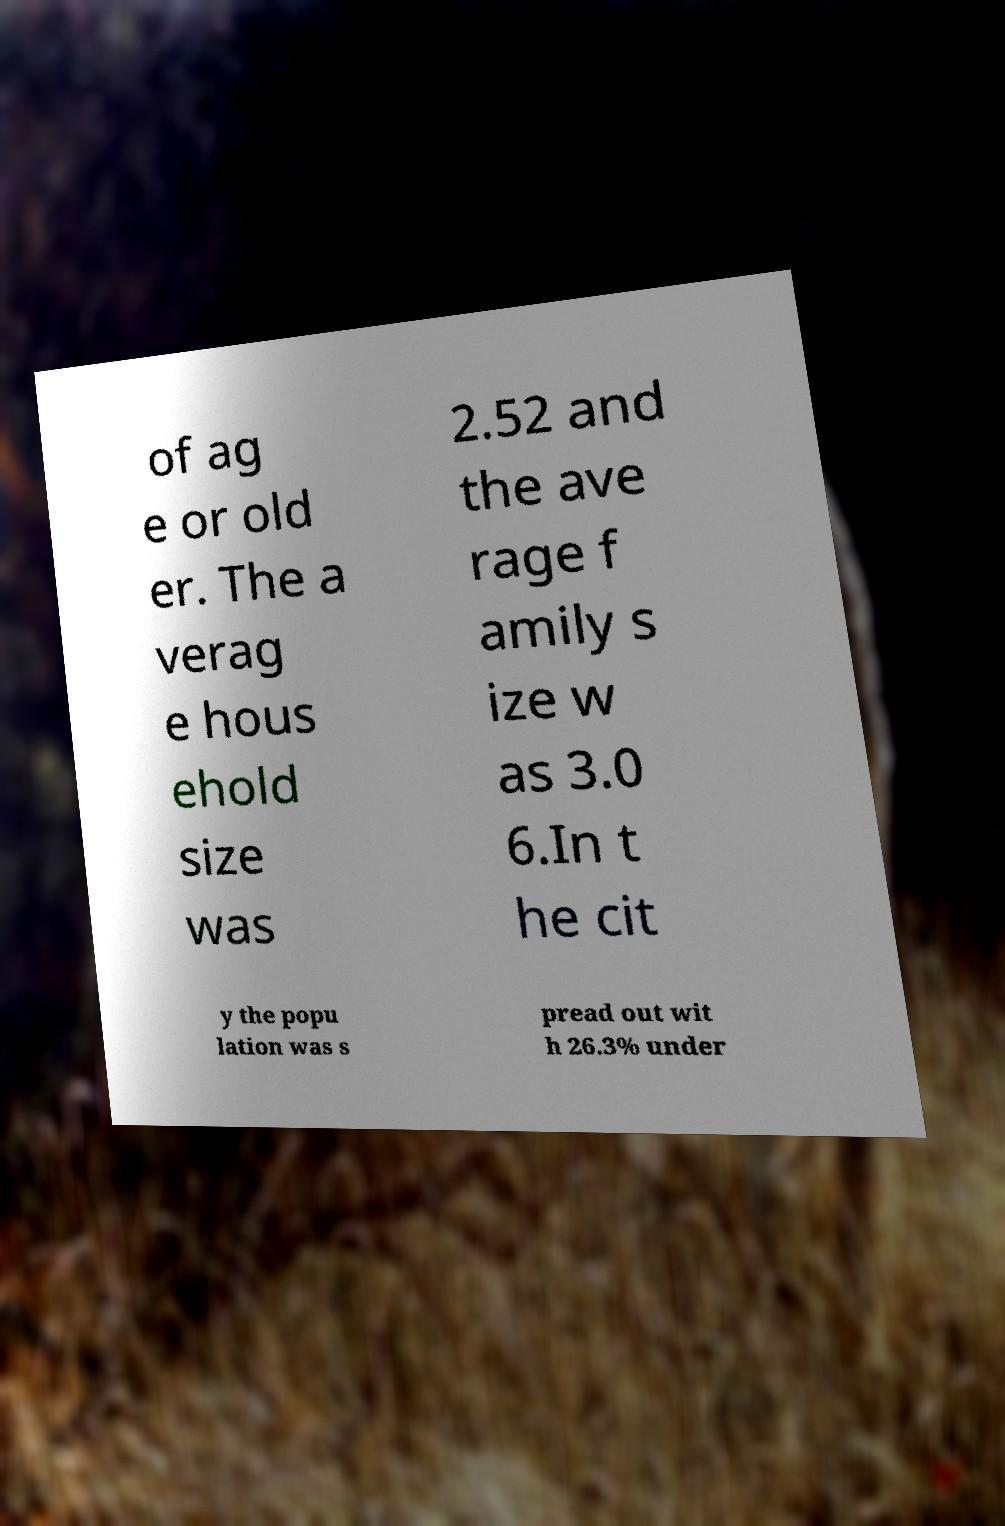Please read and relay the text visible in this image. What does it say? of ag e or old er. The a verag e hous ehold size was 2.52 and the ave rage f amily s ize w as 3.0 6.In t he cit y the popu lation was s pread out wit h 26.3% under 